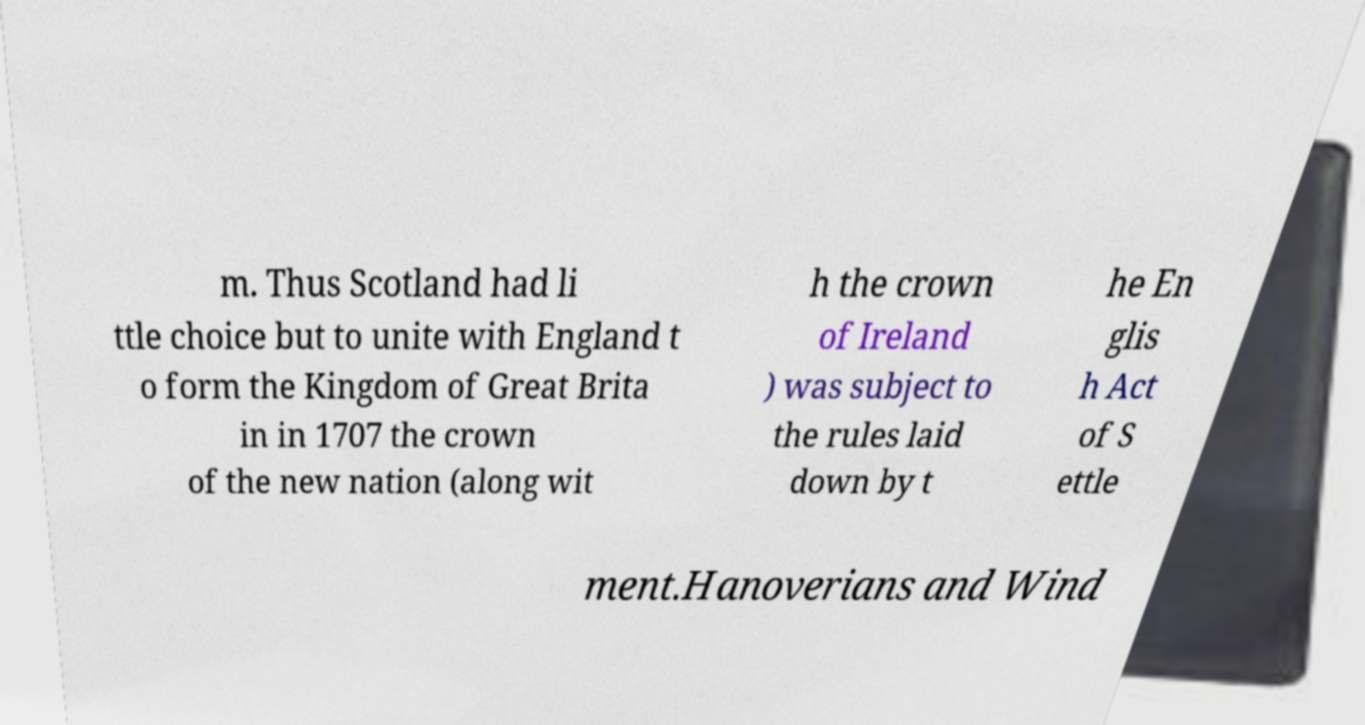What messages or text are displayed in this image? I need them in a readable, typed format. m. Thus Scotland had li ttle choice but to unite with England t o form the Kingdom of Great Brita in in 1707 the crown of the new nation (along wit h the crown of Ireland ) was subject to the rules laid down by t he En glis h Act of S ettle ment.Hanoverians and Wind 